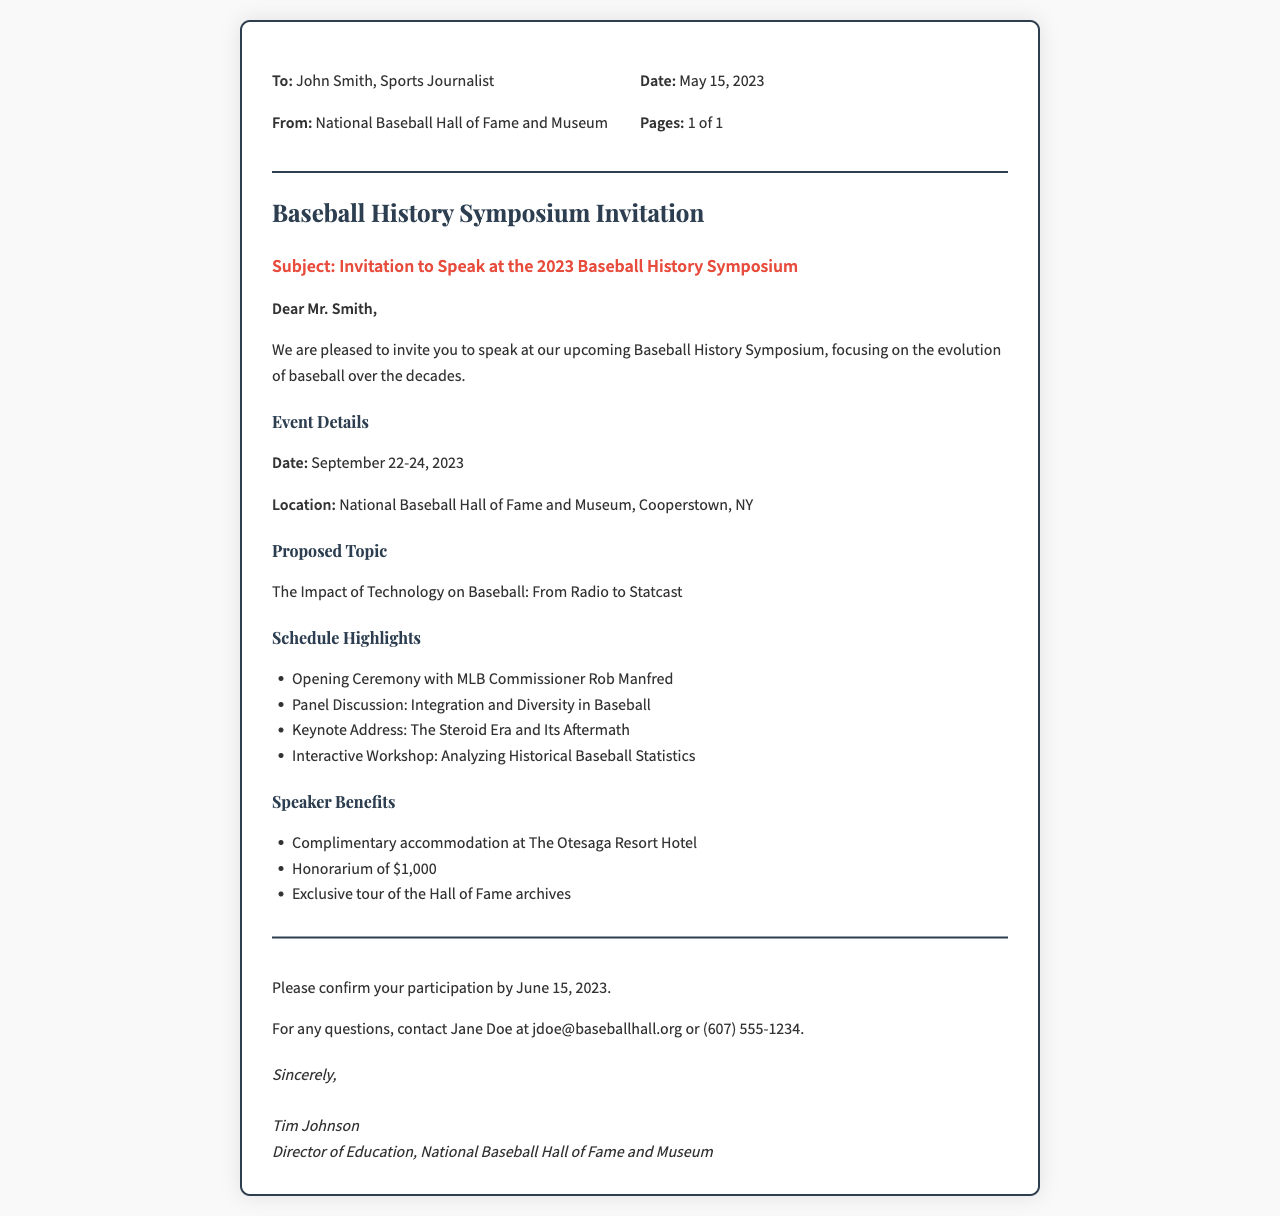what is the date of the symposium? The date of the symposium is mentioned in the event details section of the document.
Answer: September 22-24, 2023 who is the keynote speaker? The keynote speaker is mentioned in the schedule highlights section of the document.
Answer: Not specified what is the proposed topic for the speech? The proposed topic is stated in the corresponding section of the document.
Answer: The Impact of Technology on Baseball: From Radio to Statcast how much is the honorarium for speakers? The amount of the honorarium is detailed in the speaker benefits section of the document.
Answer: $1,000 what is the location of the symposium? The location is outlined in the event details section of the document.
Answer: National Baseball Hall of Fame and Museum, Cooperstown, NY who sent the invitation? The sender is identified at the top of the document in the fax details.
Answer: National Baseball Hall of Fame and Museum when is the confirmation due? The due date for confirmation is specified towards the end of the document.
Answer: June 15, 2023 what is offered as complimentary accommodation? The accommodation provided to speakers is detailed in the speaker benefits section.
Answer: The Otesaga Resort Hotel who should be contacted for questions? The contact person for questions is mentioned in the closing section of the document.
Answer: Jane Doe 